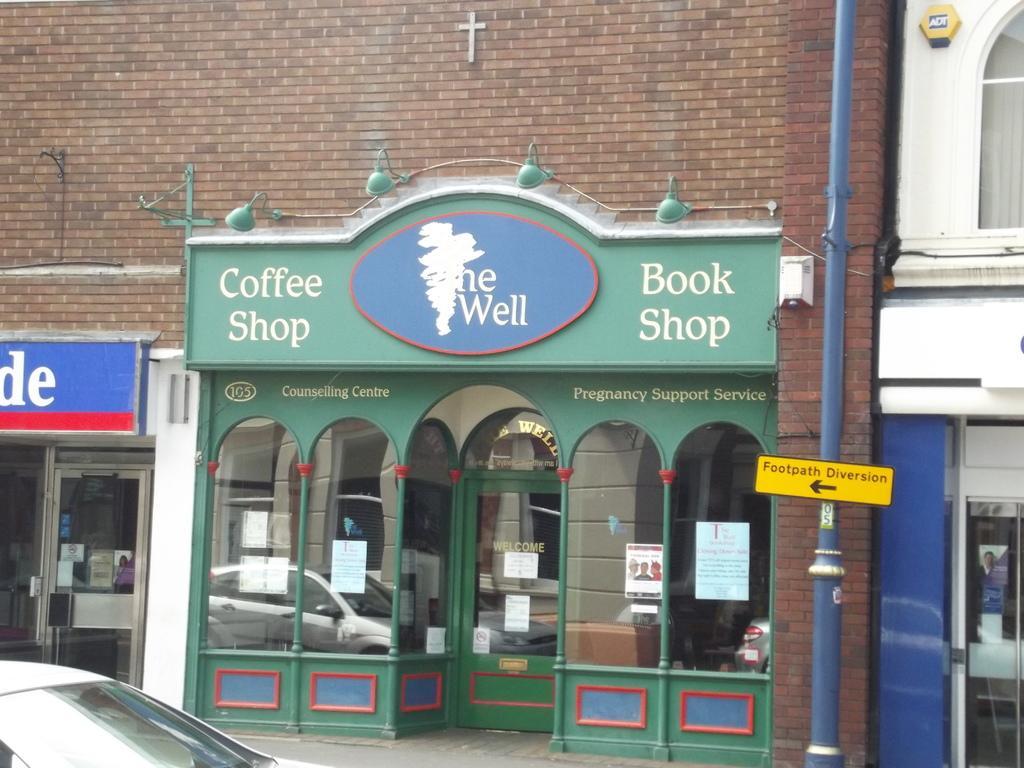Describe this image in one or two sentences. In the picture I can see the brick construction at the top of the picture. There is a building on the right side and I can see the glass window on the top right side. I can see the glass windows and a glass door of a shop at the bottom of the picture. There is a car on the bottom left side of the picture. I can see a pole on the right side and there is a direction caution board on the pole. 